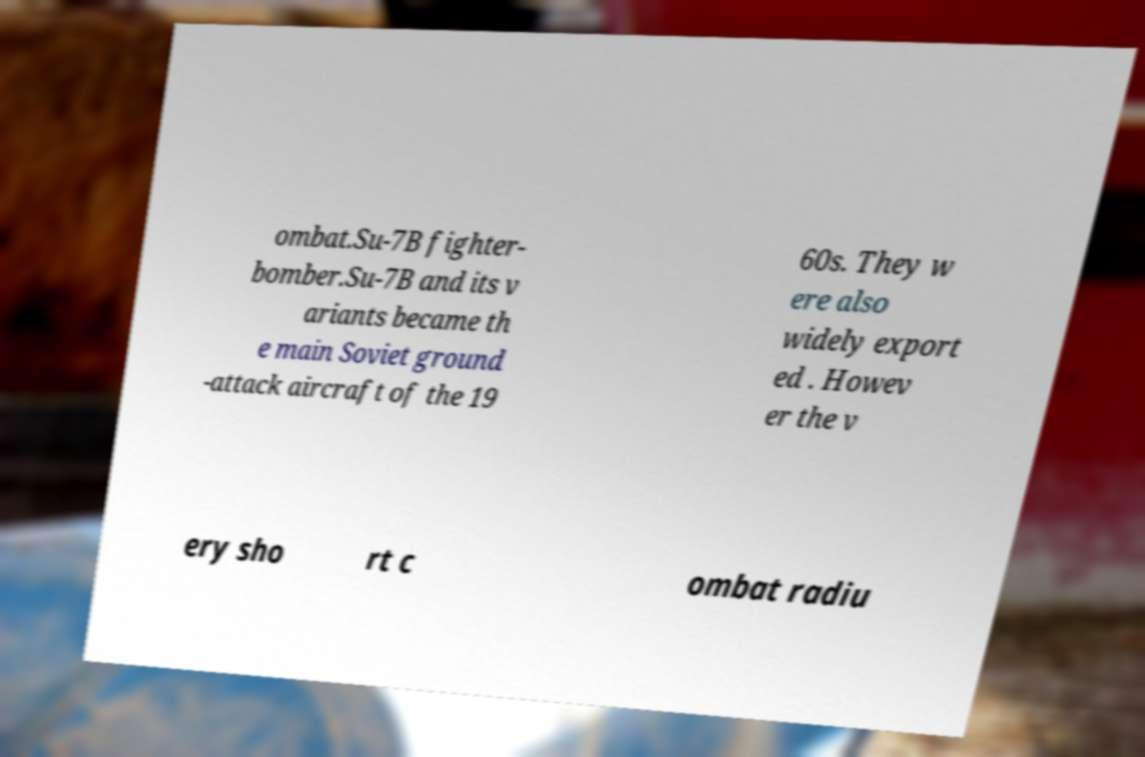I need the written content from this picture converted into text. Can you do that? ombat.Su-7B fighter- bomber.Su-7B and its v ariants became th e main Soviet ground -attack aircraft of the 19 60s. They w ere also widely export ed . Howev er the v ery sho rt c ombat radiu 